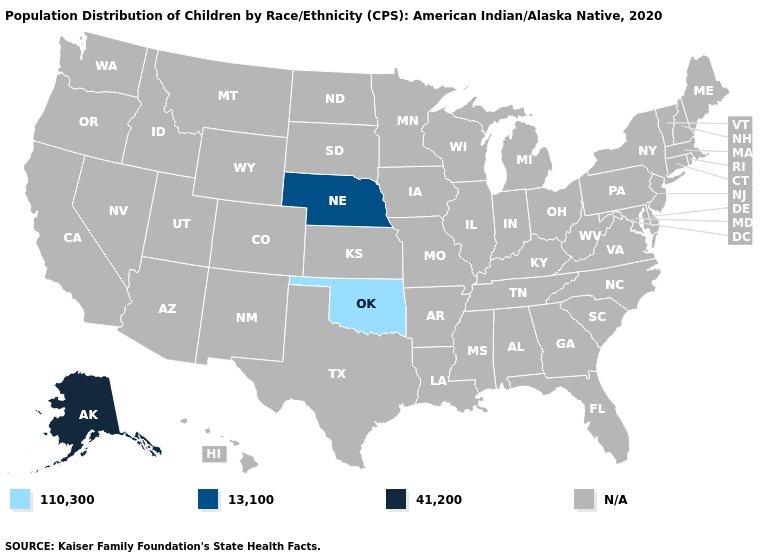Name the states that have a value in the range N/A?
Keep it brief. Alabama, Arizona, Arkansas, California, Colorado, Connecticut, Delaware, Florida, Georgia, Hawaii, Idaho, Illinois, Indiana, Iowa, Kansas, Kentucky, Louisiana, Maine, Maryland, Massachusetts, Michigan, Minnesota, Mississippi, Missouri, Montana, Nevada, New Hampshire, New Jersey, New Mexico, New York, North Carolina, North Dakota, Ohio, Oregon, Pennsylvania, Rhode Island, South Carolina, South Dakota, Tennessee, Texas, Utah, Vermont, Virginia, Washington, West Virginia, Wisconsin, Wyoming. What is the value of Iowa?
Concise answer only. N/A. What is the lowest value in the South?
Concise answer only. 110,300. Name the states that have a value in the range 13,100?
Quick response, please. Nebraska. Is the legend a continuous bar?
Write a very short answer. No. How many symbols are there in the legend?
Quick response, please. 4. Which states have the lowest value in the South?
Quick response, please. Oklahoma. Which states have the lowest value in the South?
Short answer required. Oklahoma. What is the value of Wisconsin?
Give a very brief answer. N/A. What is the highest value in the MidWest ?
Give a very brief answer. 13,100. Name the states that have a value in the range 13,100?
Be succinct. Nebraska. 